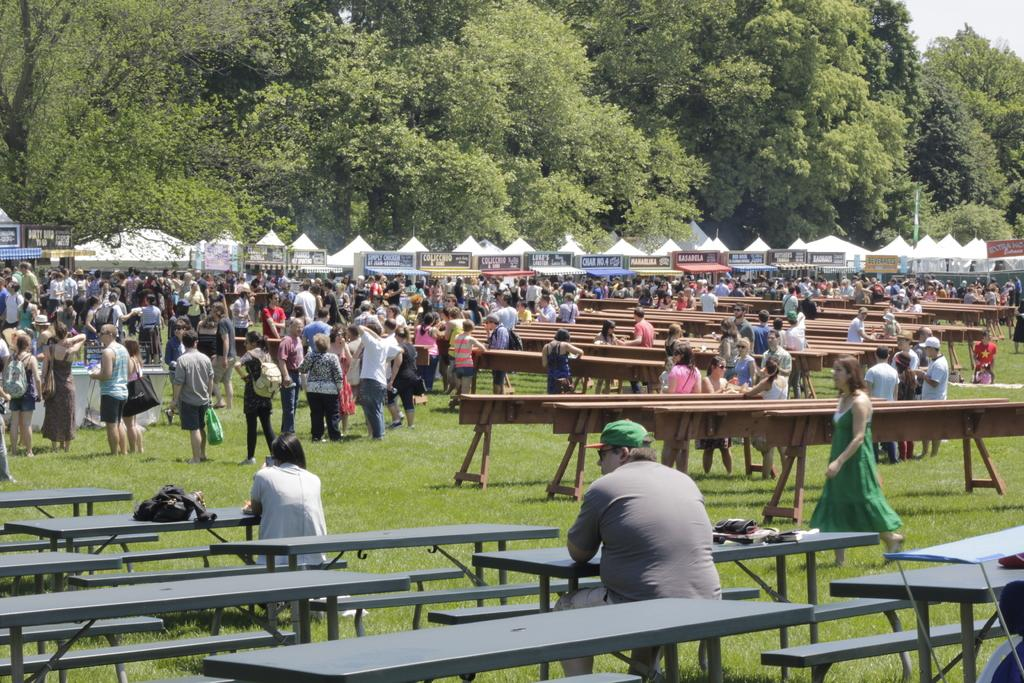How many people are in the image? There is a group of people in the image. What are some of the people doing in the image? Some of the people are standing, while two people are seated on chairs. What can be seen in the background of the image? There are trees visible in the image. What is the name of the cake that is being served in the image? There is no cake present in the image, so it cannot be determined if any cake is being served. 